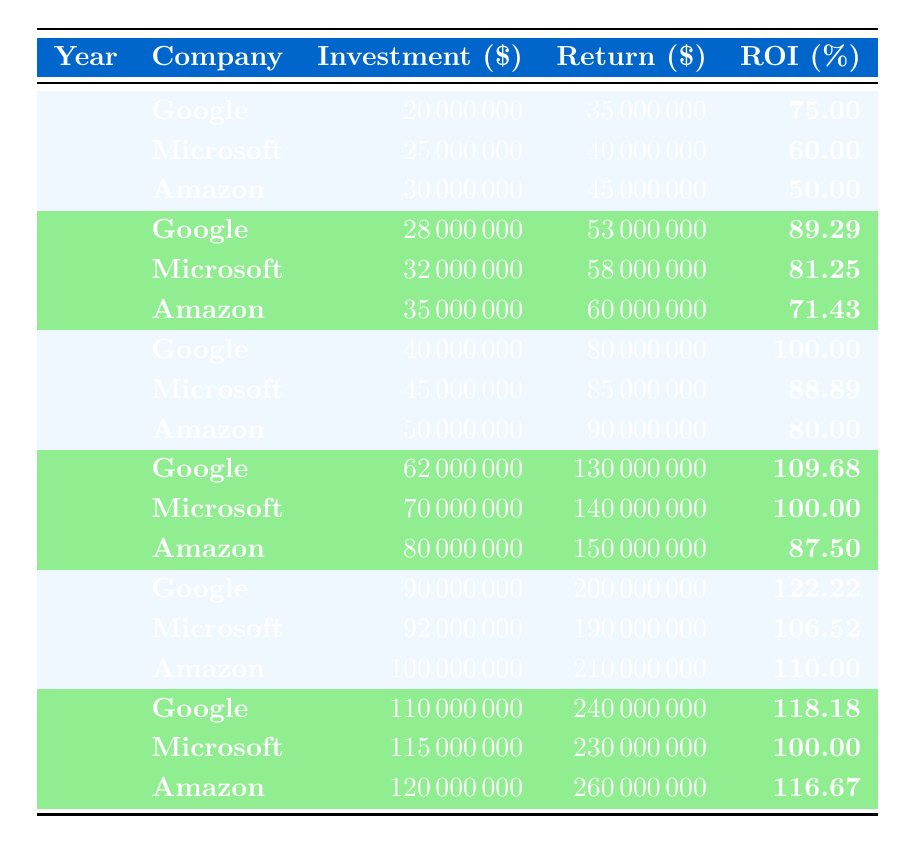What was the highest ROI percentage recorded in 2021? Looking at the table, Google had the highest ROI percentage in 2021, which is 122.22.
Answer: 122.22 What was Microsoft's investment amount in the year 2019? The table shows that Microsoft's investment amount in 2019 was 70000000.
Answer: 70000000 Which company had the lowest ROI percentage in 2013? In 2013, the table indicates that Amazon had the lowest ROI percentage at 50.00.
Answer: 50.00 What is the total investment amount for Google over the years shown in the table? Summing Google's investments: 20000000 (2013) + 28000000 (2015) + 40000000 (2017) + 62000000 (2019) + 90000000 (2021) + 110000000 (2022) gives 20000000 + 28000000 + 40000000 + 62000000 + 90000000 + 110000000 = 400000000.
Answer: 400000000 Is there any year where all companies had an ROI percentage higher than 80? Checking the table, in the year 2017, all companies (Google, Microsoft, and Amazon) had ROI percentages of 100, 88.89, and 80, respectively. Thus, there is no year where all exceeded 80.
Answer: No Which company had the greatest return amount in 2022? According to the table, Amazon had the greatest return amount in 2022 at 260000000.
Answer: 260000000 What is the difference between the highest return amount and the lowest return amount in 2015? In 2015, the return amounts were: Google 53000000, Microsoft 58000000, Amazon 60000000. The highest return is 60000000 and the lowest is 53000000. The difference is 60000000 - 53000000 = 7000000.
Answer: 7000000 In which year did Amazon achieve an ROI percentage of exactly 110? The table shows that Amazon achieved an ROI percentage of exactly 110 in 2021.
Answer: 2021 